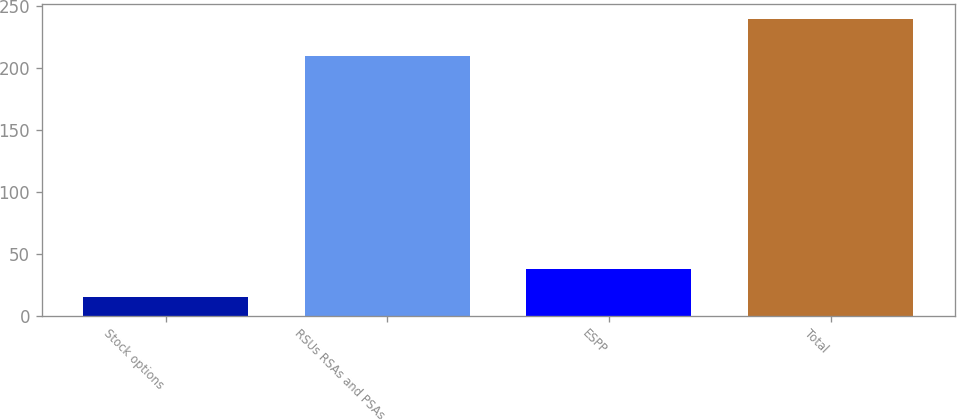Convert chart to OTSL. <chart><loc_0><loc_0><loc_500><loc_500><bar_chart><fcel>Stock options<fcel>RSUs RSAs and PSAs<fcel>ESPP<fcel>Total<nl><fcel>14.9<fcel>209.7<fcel>37.41<fcel>240<nl></chart> 